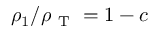Convert formula to latex. <formula><loc_0><loc_0><loc_500><loc_500>\rho _ { 1 } / \rho _ { T } = 1 - c</formula> 